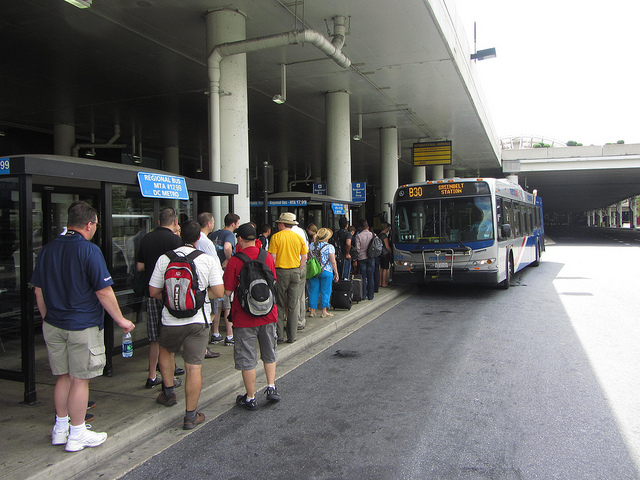Extract all visible text content from this image. 830 REGIONAL 99 METRO DC MTA 